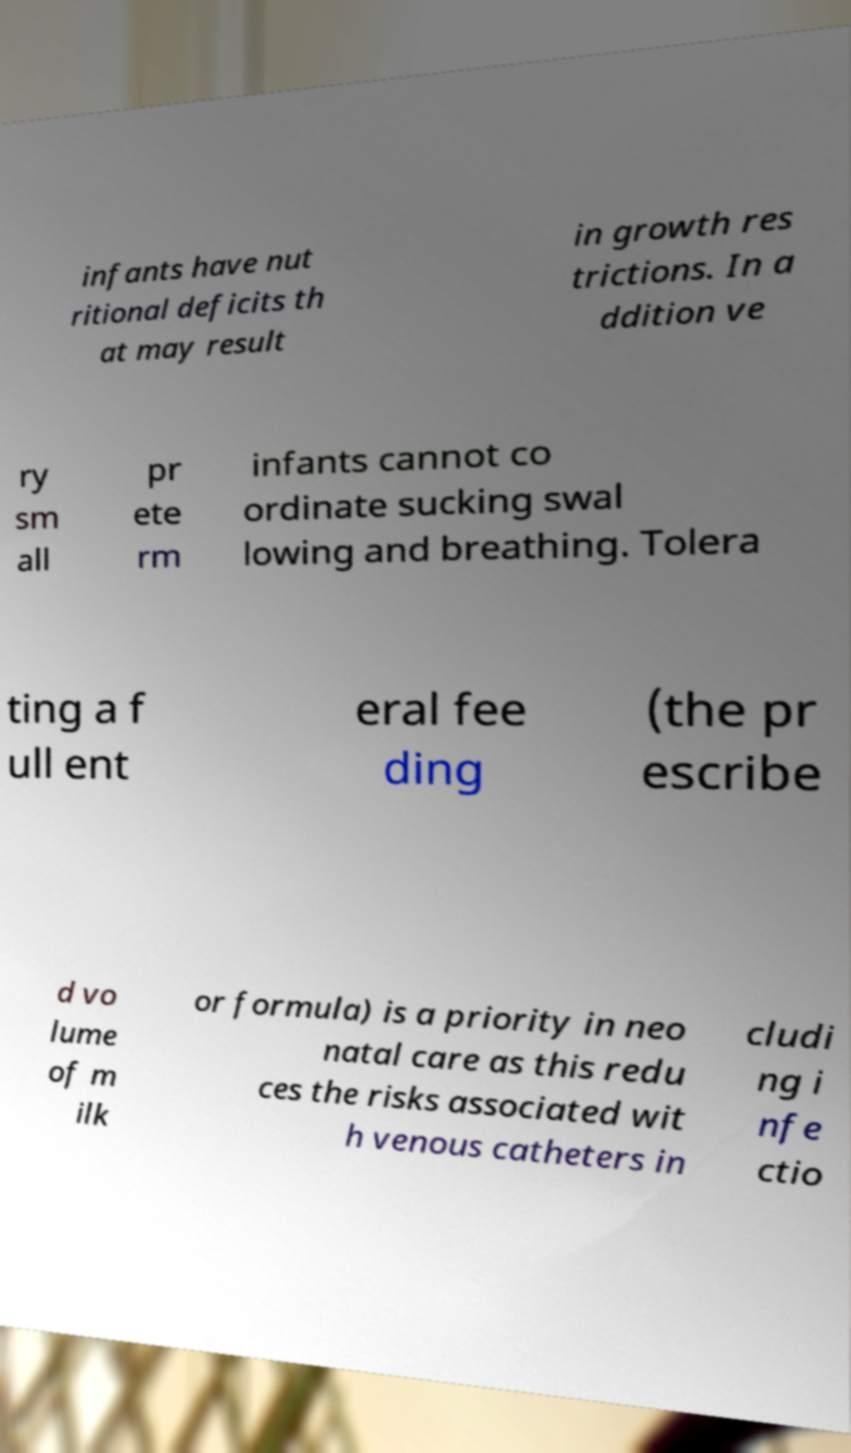Can you read and provide the text displayed in the image?This photo seems to have some interesting text. Can you extract and type it out for me? infants have nut ritional deficits th at may result in growth res trictions. In a ddition ve ry sm all pr ete rm infants cannot co ordinate sucking swal lowing and breathing. Tolera ting a f ull ent eral fee ding (the pr escribe d vo lume of m ilk or formula) is a priority in neo natal care as this redu ces the risks associated wit h venous catheters in cludi ng i nfe ctio 